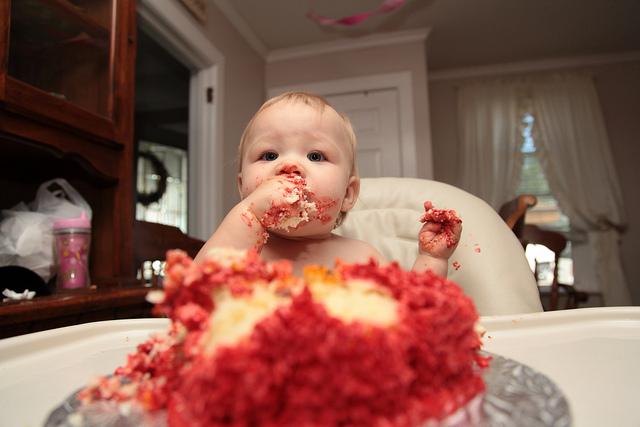Was the picture taken during the daytime?
Give a very brief answer. Yes. Is the baby eating cake?
Give a very brief answer. Yes. Is the child eating neatly?
Give a very brief answer. No. 